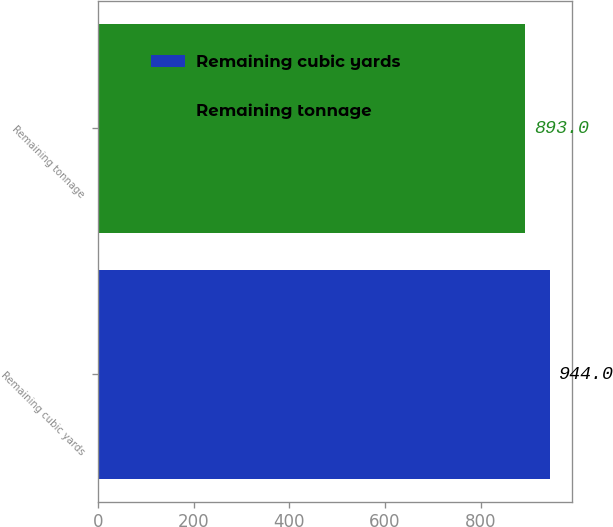Convert chart to OTSL. <chart><loc_0><loc_0><loc_500><loc_500><bar_chart><fcel>Remaining cubic yards<fcel>Remaining tonnage<nl><fcel>944<fcel>893<nl></chart> 